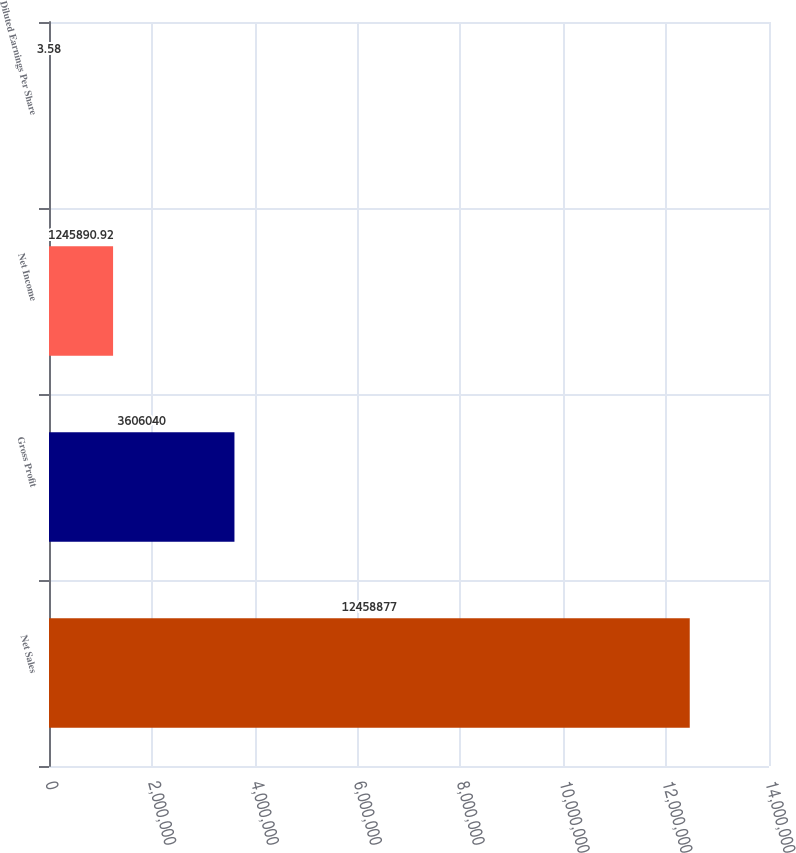Convert chart. <chart><loc_0><loc_0><loc_500><loc_500><bar_chart><fcel>Net Sales<fcel>Gross Profit<fcel>Net Income<fcel>Diluted Earnings Per Share<nl><fcel>1.24589e+07<fcel>3.60604e+06<fcel>1.24589e+06<fcel>3.58<nl></chart> 